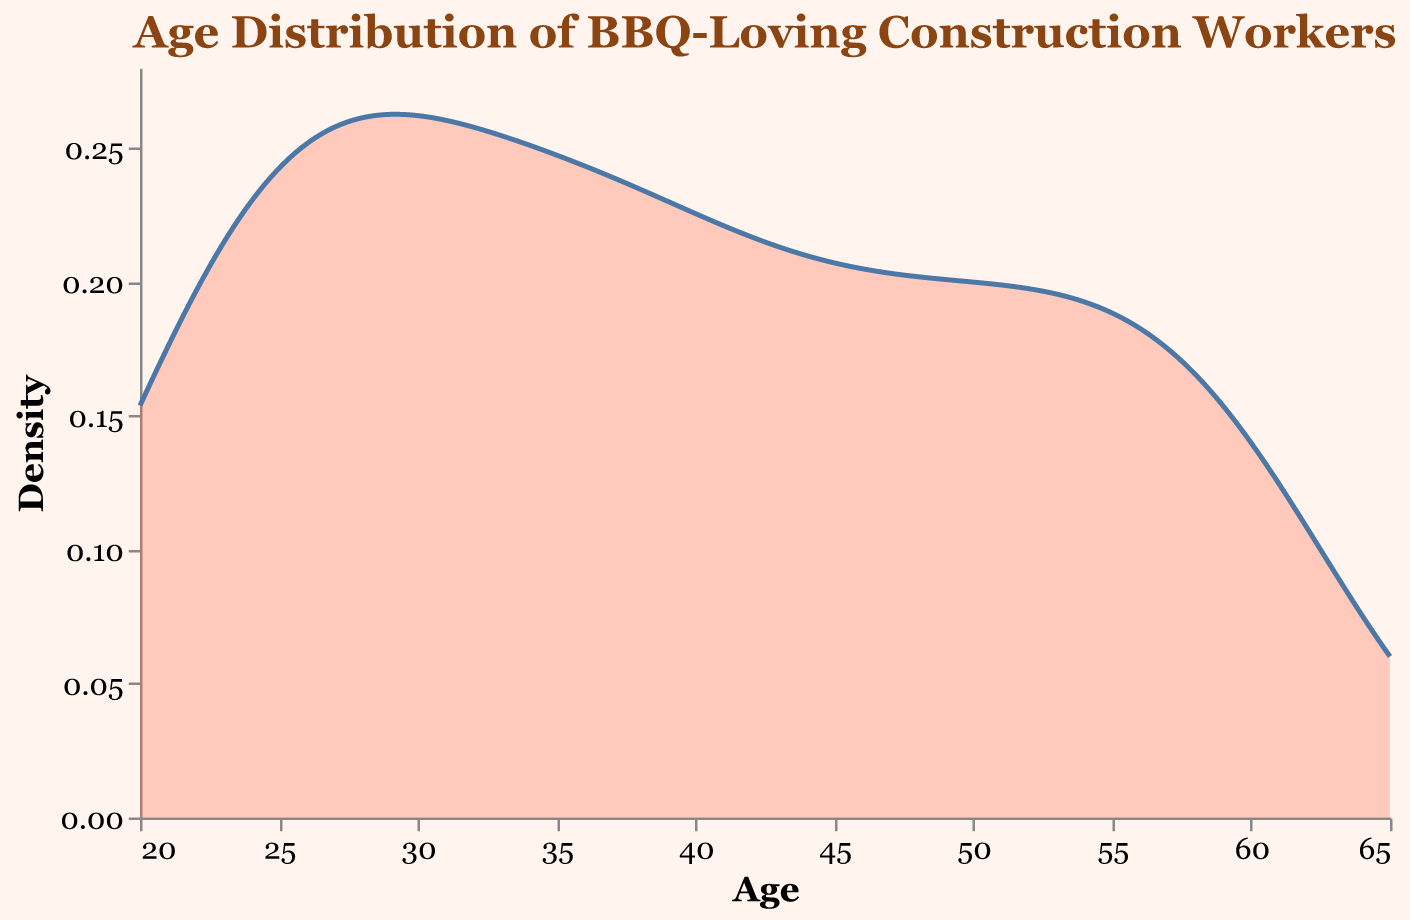What is the title of the plot? The title is located at the top of the figure and reads "Age Distribution of BBQ-Loving Construction Workers," which conveys the subject of the plot.
Answer: Age Distribution of BBQ-Loving Construction Workers What is the axis label for the x-axis? The x-axis label is found below the horizontal axis and is labeled "Age," indicating what the horizontal axis measures.
Answer: Age Which age group has the highest density of participants? The highest peak in the density plot represents the age group with the most participants. By observing the plot, the age 28 group has the highest density, illustrated by the highest peak.
Answer: Age 28 How many participants are there in the age group 28? The data indicates that there are 45 participants in the age group 28, which matches the age group with the highest density in the plot.
Answer: 45 What is the density value at age 50? By tracing the plot, the value at age 50 can be identified near the curve for age 50. The density is about 0.03.
Answer: Approximately 0.03 Compare the density of participants aged 32 and 36. Which is higher? By examining the height of the density plot at ages 32 and 36, age 32 has a higher peak than age 36 since the curve is higher at age 32.
Answer: Age 32 What is the general trend in the number of participants as age increases from 21 to 60? The plot shows an overall downward trend in density from the initial peak at age 28. There are more participants in the younger age groups (20s and early 30s) and fewer participants in the older age groups (40s and 50s).
Answer: Decreasing trend Between which two age groups is the drop in participation most significant? The most significant drop can be identified by looking for the steepest decline in the density plot. The drop is most notable between ages 28 and 45, where the density sharply decreases.
Answer: Between ages 28 and 45 What is the age with the lowest density of participants? Observing the lowest point on the density plot, age 60 has the smallest peak, thus the lowest density.
Answer: Age 60 